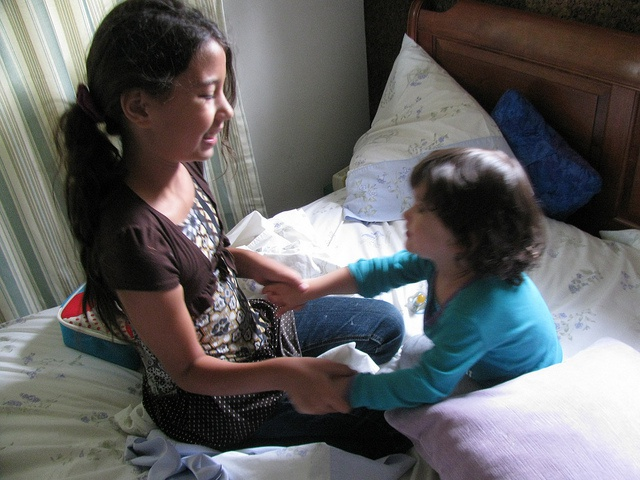Describe the objects in this image and their specific colors. I can see people in gray, black, maroon, and lightgray tones, bed in gray, lavender, darkgray, and black tones, and people in gray, black, blue, and teal tones in this image. 